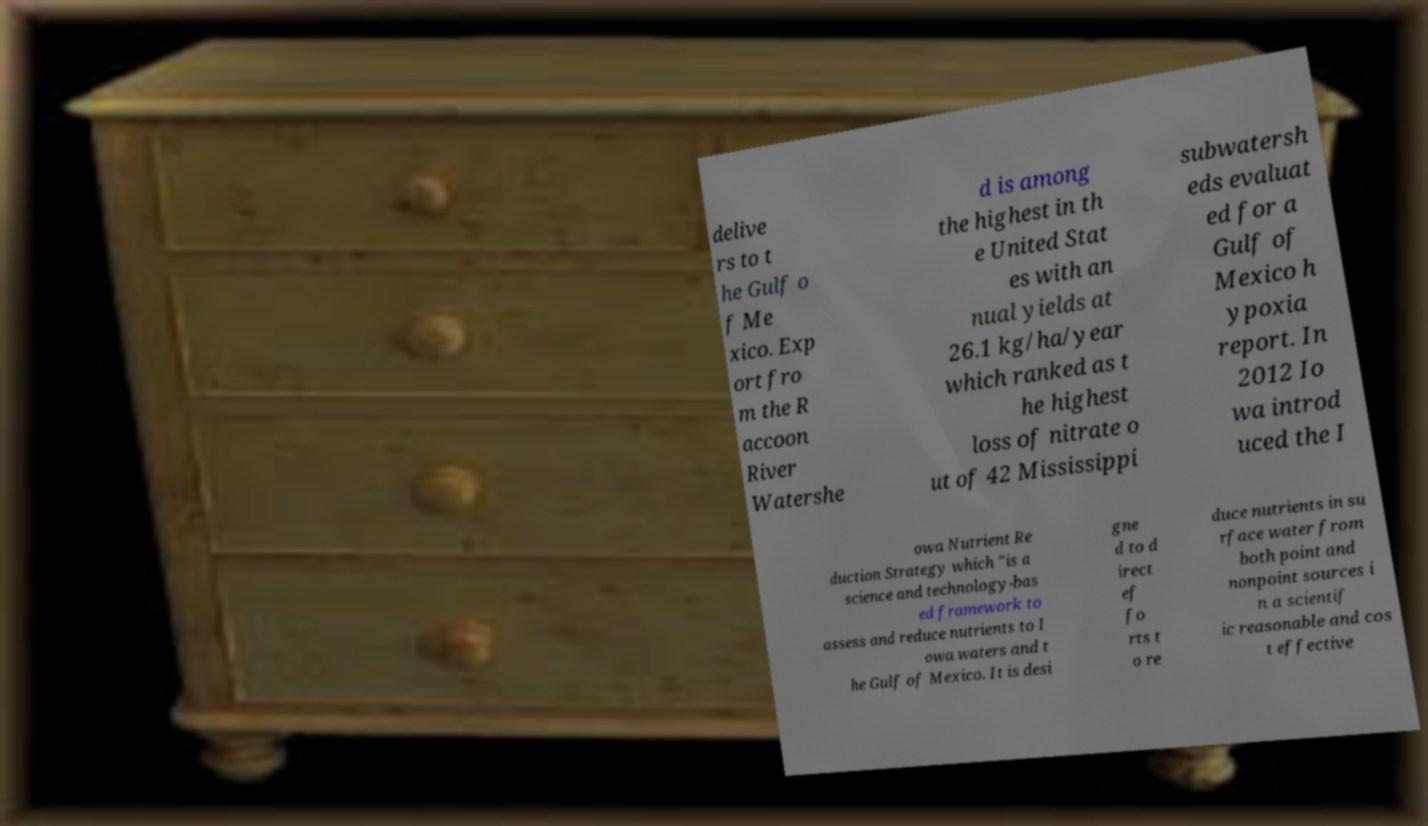What messages or text are displayed in this image? I need them in a readable, typed format. delive rs to t he Gulf o f Me xico. Exp ort fro m the R accoon River Watershe d is among the highest in th e United Stat es with an nual yields at 26.1 kg/ha/year which ranked as t he highest loss of nitrate o ut of 42 Mississippi subwatersh eds evaluat ed for a Gulf of Mexico h ypoxia report. In 2012 Io wa introd uced the I owa Nutrient Re duction Strategy which "is a science and technology-bas ed framework to assess and reduce nutrients to I owa waters and t he Gulf of Mexico. It is desi gne d to d irect ef fo rts t o re duce nutrients in su rface water from both point and nonpoint sources i n a scientif ic reasonable and cos t effective 